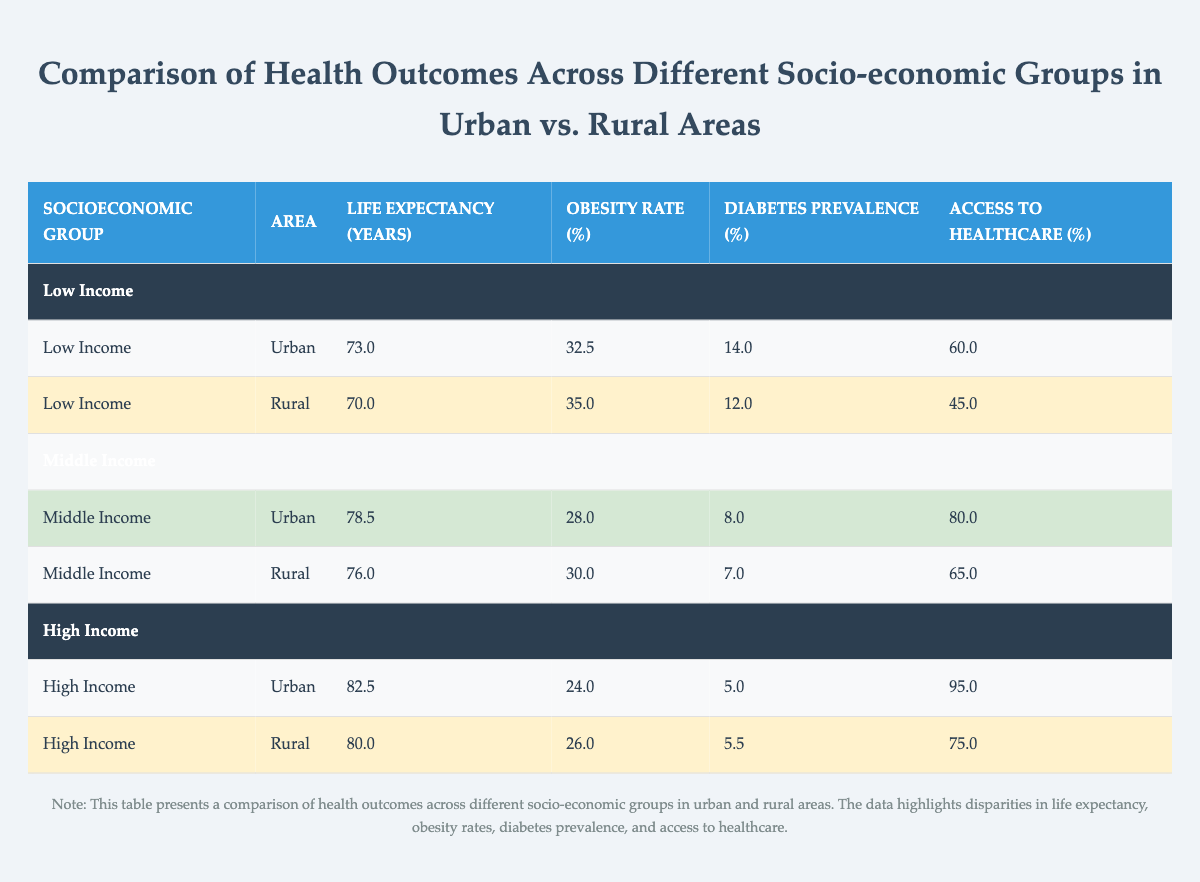What is the life expectancy for Low Income individuals in urban areas? The table shows that for Low Income individuals in urban areas, the life expectancy is listed as 73.0 years.
Answer: 73.0 What is the obesity rate for High Income groups in rural areas? According to the table, the obesity rate for High Income individuals in rural areas is 26.0%.
Answer: 26.0% Is the access to healthcare higher for Middle Income groups in urban areas compared to rural areas? The table shows an access to healthcare rate of 80.0% for Middle Income in urban areas and 65.0% in rural areas. Therefore, it is higher for urban areas.
Answer: Yes What is the difference in diabetes prevalence between Low Income urban and rural populations? The diabetes prevalence for Low Income in urban areas is 14.0%, while in rural areas, it is 12.0%. The difference is calculated as 14.0 - 12.0 = 2.0%.
Answer: 2.0% What is the average life expectancy across all socio-economic groups in urban areas? To find the average life expectancy in urban areas, add the life expectancies: 73.0 (Low Income) + 78.5 (Middle Income) + 82.5 (High Income) = 234.0. There are 3 groups, so the average is 234.0 / 3 = 78.0 years.
Answer: 78.0 What is the obesity rate for all socio-economic groups combined in urban areas compared to rural areas? To compare, we find the obesity rates: Urban rates are 32.5% (Low Income), 28.0% (Middle Income), and 24.0% (High Income), giving an average of (32.5 + 28.0 + 24.0) / 3 = 28.5%. For rural areas, the rates are 35.0%, 30.0%, and 26.0%, averaging (35.0 + 30.0 + 26.0) / 3 = 30.33%. Comparing both averages (28.5% vs. 30.33%), we find that urban areas have a lower average obesity rate.
Answer: Urban areas have a lower average obesity rate Is it true that individuals from the High Income group have better access to healthcare than those from the Low Income group in rural areas? In the table, High Income individuals in rural areas have access to healthcare at 75.0%, while Low Income individuals have access at 45.0%. Therefore, High Income individuals have better access.
Answer: Yes 